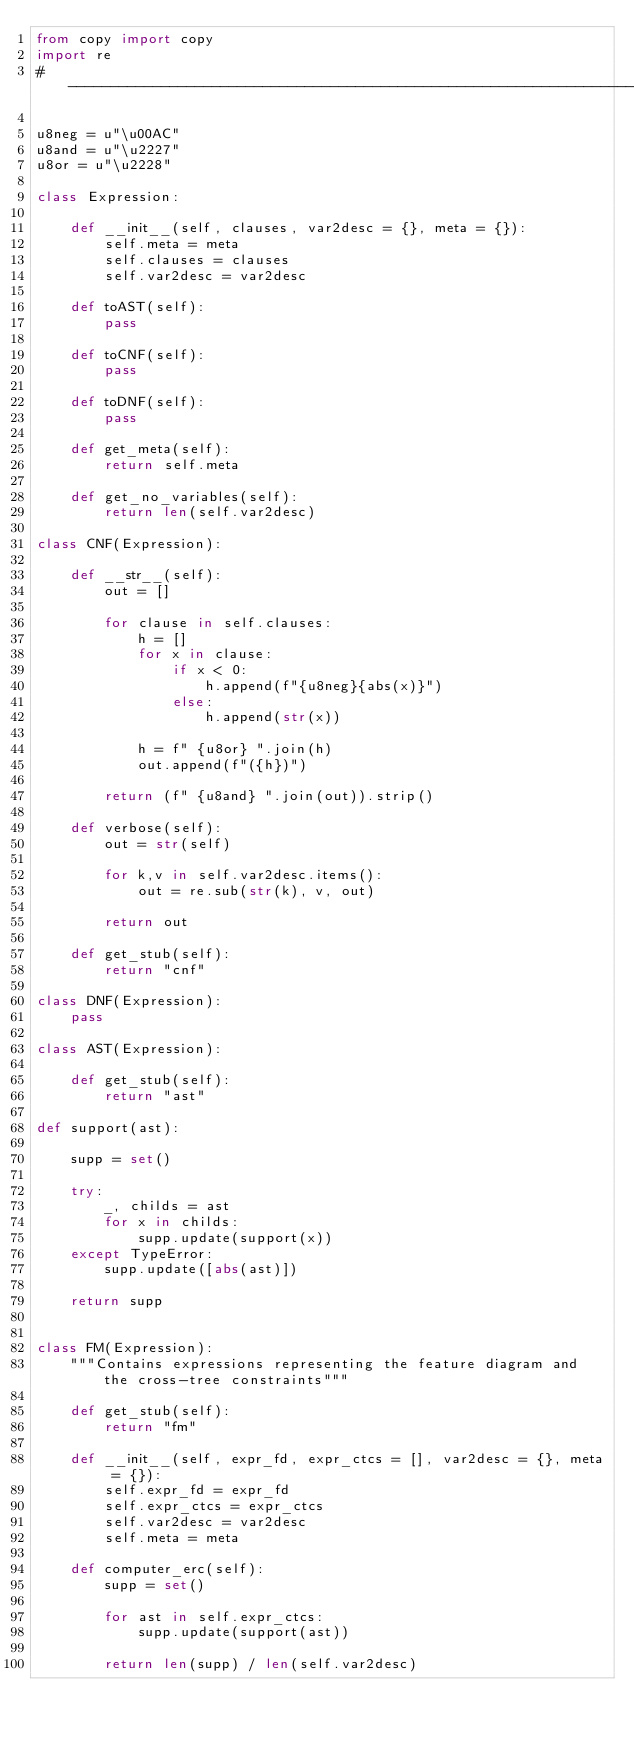Convert code to text. <code><loc_0><loc_0><loc_500><loc_500><_Python_>from copy import copy
import re
#------------------------------------------------------------------------------#

u8neg = u"\u00AC"
u8and = u"\u2227"
u8or = u"\u2228"

class Expression:
    
    def __init__(self, clauses, var2desc = {}, meta = {}):
        self.meta = meta
        self.clauses = clauses
        self.var2desc = var2desc

    def toAST(self):
        pass

    def toCNF(self):
        pass

    def toDNF(self):
        pass

    def get_meta(self):
        return self.meta

    def get_no_variables(self):
        return len(self.var2desc)

class CNF(Expression):

    def __str__(self):
        out = []

        for clause in self.clauses:
            h = []
            for x in clause:
                if x < 0:
                    h.append(f"{u8neg}{abs(x)}")
                else:
                    h.append(str(x))

            h = f" {u8or} ".join(h)
            out.append(f"({h})")

        return (f" {u8and} ".join(out)).strip()

    def verbose(self):        
        out = str(self)

        for k,v in self.var2desc.items():
            out = re.sub(str(k), v, out)

        return out

    def get_stub(self):
        return "cnf"

class DNF(Expression):
    pass

class AST(Expression):
    
    def get_stub(self):
        return "ast"

def support(ast):

    supp = set()

    try:
        _, childs = ast
        for x in childs:
            supp.update(support(x))
    except TypeError:
        supp.update([abs(ast)])

    return supp


class FM(Expression):
    """Contains expressions representing the feature diagram and the cross-tree constraints"""

    def get_stub(self):
        return "fm"

    def __init__(self, expr_fd, expr_ctcs = [], var2desc = {}, meta = {}):
        self.expr_fd = expr_fd
        self.expr_ctcs = expr_ctcs
        self.var2desc = var2desc
        self.meta = meta

    def computer_erc(self):
        supp = set()

        for ast in self.expr_ctcs:
            supp.update(support(ast))

        return len(supp) / len(self.var2desc)



</code> 